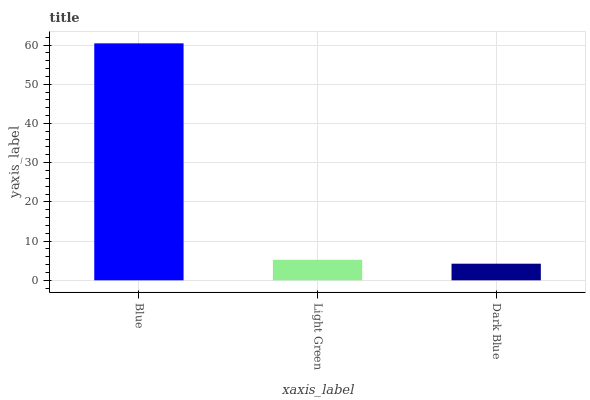Is Dark Blue the minimum?
Answer yes or no. Yes. Is Blue the maximum?
Answer yes or no. Yes. Is Light Green the minimum?
Answer yes or no. No. Is Light Green the maximum?
Answer yes or no. No. Is Blue greater than Light Green?
Answer yes or no. Yes. Is Light Green less than Blue?
Answer yes or no. Yes. Is Light Green greater than Blue?
Answer yes or no. No. Is Blue less than Light Green?
Answer yes or no. No. Is Light Green the high median?
Answer yes or no. Yes. Is Light Green the low median?
Answer yes or no. Yes. Is Blue the high median?
Answer yes or no. No. Is Blue the low median?
Answer yes or no. No. 